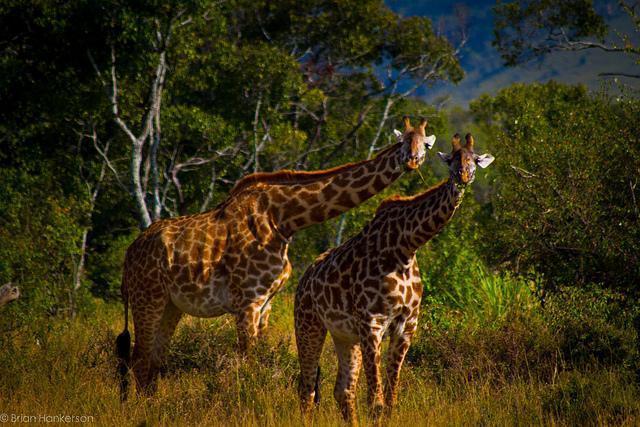How many giraffes are there?
Give a very brief answer. 2. How many giraffes are in the picture?
Give a very brief answer. 2. How many animals?
Give a very brief answer. 2. 